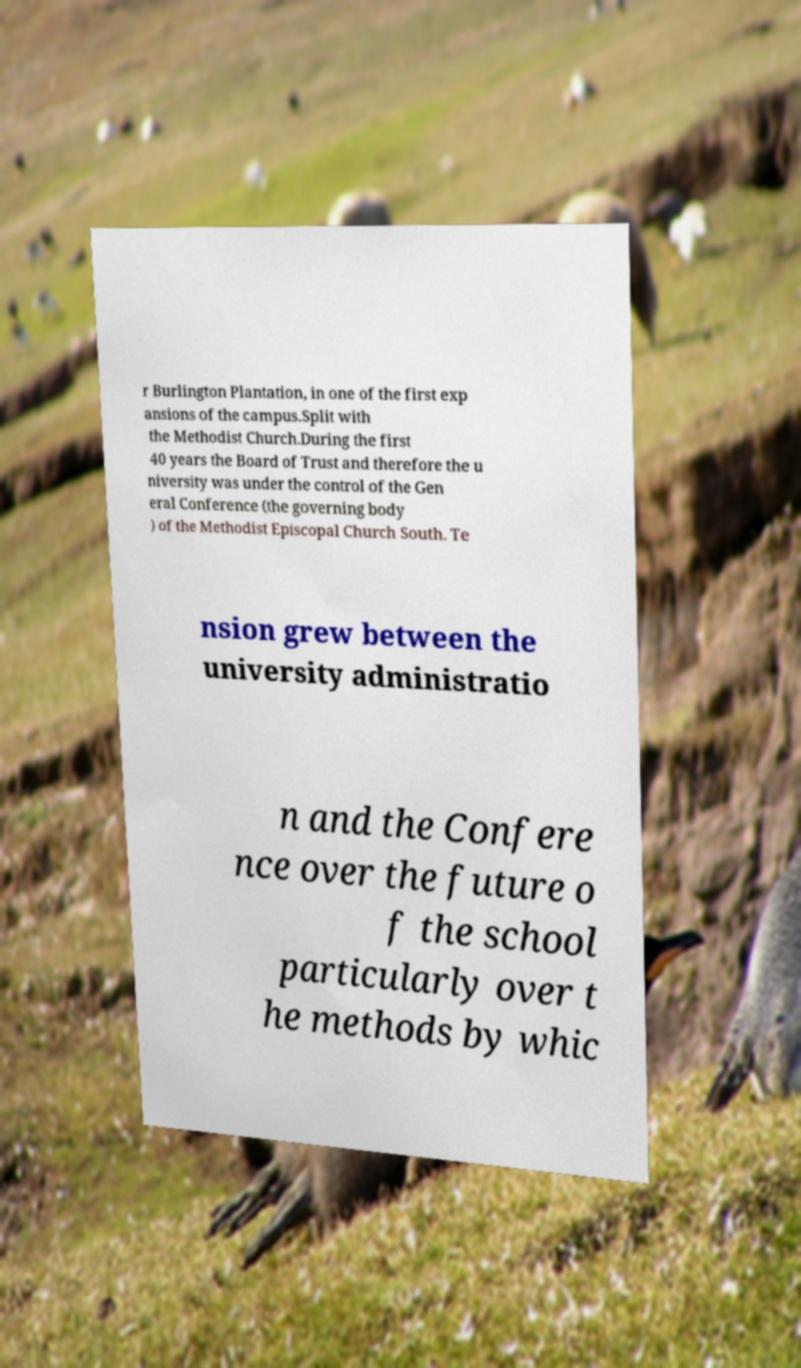Can you read and provide the text displayed in the image?This photo seems to have some interesting text. Can you extract and type it out for me? r Burlington Plantation, in one of the first exp ansions of the campus.Split with the Methodist Church.During the first 40 years the Board of Trust and therefore the u niversity was under the control of the Gen eral Conference (the governing body ) of the Methodist Episcopal Church South. Te nsion grew between the university administratio n and the Confere nce over the future o f the school particularly over t he methods by whic 